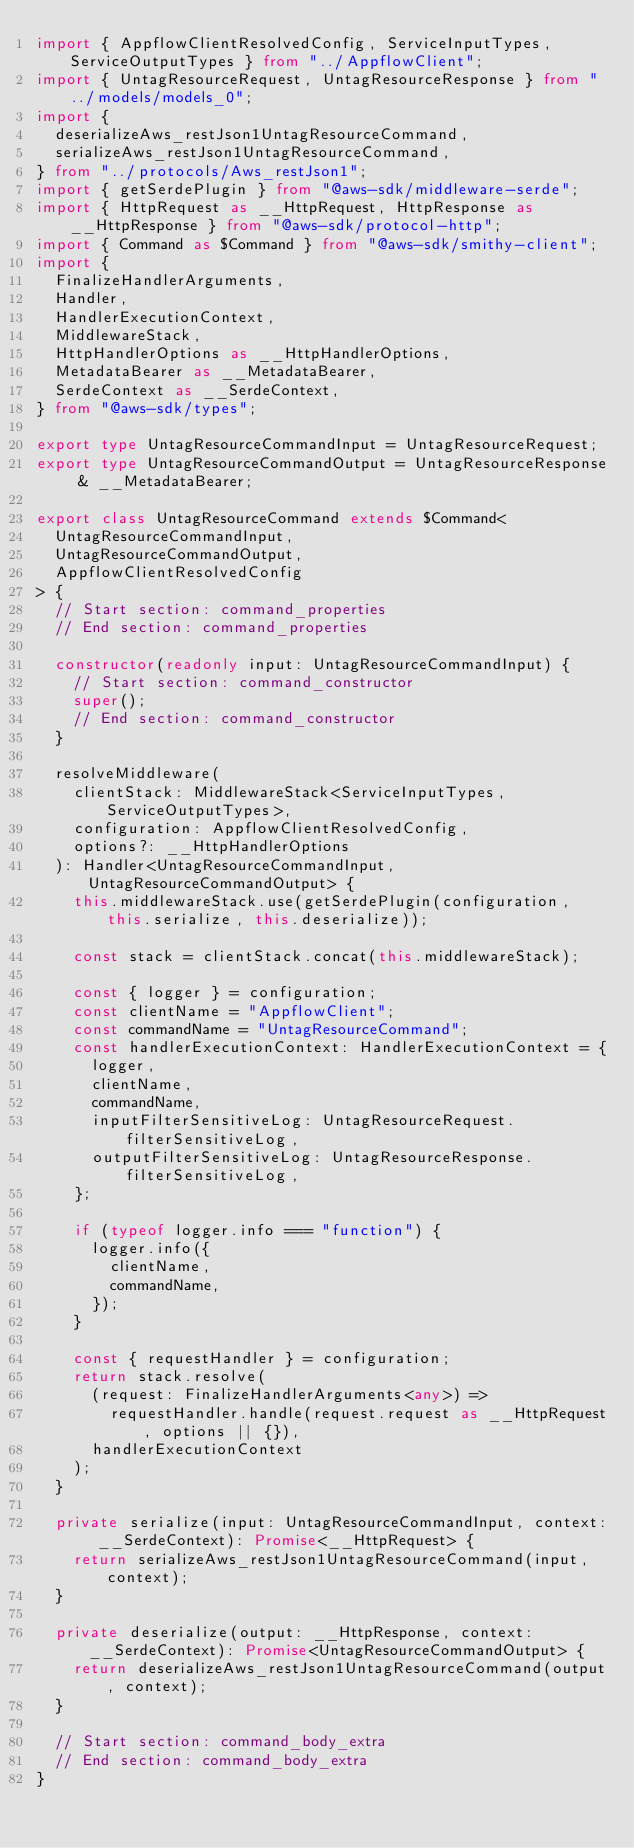<code> <loc_0><loc_0><loc_500><loc_500><_TypeScript_>import { AppflowClientResolvedConfig, ServiceInputTypes, ServiceOutputTypes } from "../AppflowClient";
import { UntagResourceRequest, UntagResourceResponse } from "../models/models_0";
import {
  deserializeAws_restJson1UntagResourceCommand,
  serializeAws_restJson1UntagResourceCommand,
} from "../protocols/Aws_restJson1";
import { getSerdePlugin } from "@aws-sdk/middleware-serde";
import { HttpRequest as __HttpRequest, HttpResponse as __HttpResponse } from "@aws-sdk/protocol-http";
import { Command as $Command } from "@aws-sdk/smithy-client";
import {
  FinalizeHandlerArguments,
  Handler,
  HandlerExecutionContext,
  MiddlewareStack,
  HttpHandlerOptions as __HttpHandlerOptions,
  MetadataBearer as __MetadataBearer,
  SerdeContext as __SerdeContext,
} from "@aws-sdk/types";

export type UntagResourceCommandInput = UntagResourceRequest;
export type UntagResourceCommandOutput = UntagResourceResponse & __MetadataBearer;

export class UntagResourceCommand extends $Command<
  UntagResourceCommandInput,
  UntagResourceCommandOutput,
  AppflowClientResolvedConfig
> {
  // Start section: command_properties
  // End section: command_properties

  constructor(readonly input: UntagResourceCommandInput) {
    // Start section: command_constructor
    super();
    // End section: command_constructor
  }

  resolveMiddleware(
    clientStack: MiddlewareStack<ServiceInputTypes, ServiceOutputTypes>,
    configuration: AppflowClientResolvedConfig,
    options?: __HttpHandlerOptions
  ): Handler<UntagResourceCommandInput, UntagResourceCommandOutput> {
    this.middlewareStack.use(getSerdePlugin(configuration, this.serialize, this.deserialize));

    const stack = clientStack.concat(this.middlewareStack);

    const { logger } = configuration;
    const clientName = "AppflowClient";
    const commandName = "UntagResourceCommand";
    const handlerExecutionContext: HandlerExecutionContext = {
      logger,
      clientName,
      commandName,
      inputFilterSensitiveLog: UntagResourceRequest.filterSensitiveLog,
      outputFilterSensitiveLog: UntagResourceResponse.filterSensitiveLog,
    };

    if (typeof logger.info === "function") {
      logger.info({
        clientName,
        commandName,
      });
    }

    const { requestHandler } = configuration;
    return stack.resolve(
      (request: FinalizeHandlerArguments<any>) =>
        requestHandler.handle(request.request as __HttpRequest, options || {}),
      handlerExecutionContext
    );
  }

  private serialize(input: UntagResourceCommandInput, context: __SerdeContext): Promise<__HttpRequest> {
    return serializeAws_restJson1UntagResourceCommand(input, context);
  }

  private deserialize(output: __HttpResponse, context: __SerdeContext): Promise<UntagResourceCommandOutput> {
    return deserializeAws_restJson1UntagResourceCommand(output, context);
  }

  // Start section: command_body_extra
  // End section: command_body_extra
}
</code> 